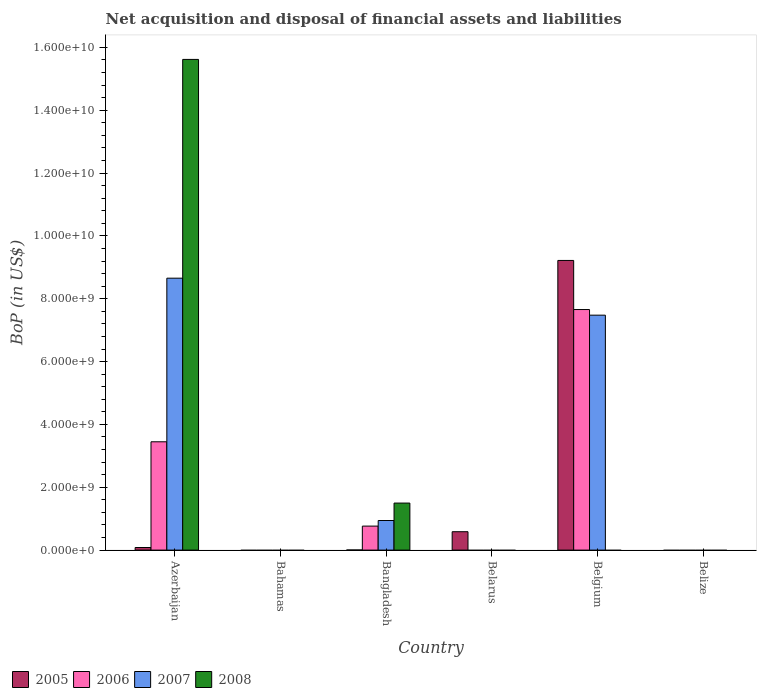How many different coloured bars are there?
Provide a succinct answer. 4. Are the number of bars per tick equal to the number of legend labels?
Offer a terse response. No. How many bars are there on the 4th tick from the left?
Provide a succinct answer. 1. How many bars are there on the 3rd tick from the right?
Make the answer very short. 1. What is the label of the 5th group of bars from the left?
Provide a succinct answer. Belgium. What is the Balance of Payments in 2006 in Bangladesh?
Your response must be concise. 7.64e+08. Across all countries, what is the maximum Balance of Payments in 2008?
Your answer should be very brief. 1.56e+1. Across all countries, what is the minimum Balance of Payments in 2007?
Ensure brevity in your answer.  0. In which country was the Balance of Payments in 2007 maximum?
Keep it short and to the point. Azerbaijan. What is the total Balance of Payments in 2006 in the graph?
Offer a very short reply. 1.19e+1. What is the difference between the Balance of Payments in 2006 in Azerbaijan and that in Bangladesh?
Your answer should be very brief. 2.68e+09. What is the difference between the Balance of Payments in 2006 in Azerbaijan and the Balance of Payments in 2007 in Belize?
Provide a succinct answer. 3.45e+09. What is the average Balance of Payments in 2006 per country?
Keep it short and to the point. 1.98e+09. What is the difference between the Balance of Payments of/in 2007 and Balance of Payments of/in 2006 in Azerbaijan?
Give a very brief answer. 5.21e+09. What is the difference between the highest and the second highest Balance of Payments in 2005?
Give a very brief answer. 5.03e+08. What is the difference between the highest and the lowest Balance of Payments in 2005?
Provide a succinct answer. 9.22e+09. How many bars are there?
Provide a succinct answer. 12. What is the difference between two consecutive major ticks on the Y-axis?
Keep it short and to the point. 2.00e+09. Are the values on the major ticks of Y-axis written in scientific E-notation?
Provide a succinct answer. Yes. Does the graph contain grids?
Offer a very short reply. No. Where does the legend appear in the graph?
Your answer should be very brief. Bottom left. What is the title of the graph?
Ensure brevity in your answer.  Net acquisition and disposal of financial assets and liabilities. Does "1961" appear as one of the legend labels in the graph?
Your answer should be very brief. No. What is the label or title of the X-axis?
Your answer should be very brief. Country. What is the label or title of the Y-axis?
Ensure brevity in your answer.  BoP (in US$). What is the BoP (in US$) in 2005 in Azerbaijan?
Your answer should be very brief. 8.26e+07. What is the BoP (in US$) of 2006 in Azerbaijan?
Ensure brevity in your answer.  3.45e+09. What is the BoP (in US$) in 2007 in Azerbaijan?
Offer a very short reply. 8.66e+09. What is the BoP (in US$) of 2008 in Azerbaijan?
Offer a very short reply. 1.56e+1. What is the BoP (in US$) of 2005 in Bahamas?
Ensure brevity in your answer.  0. What is the BoP (in US$) of 2006 in Bahamas?
Make the answer very short. 0. What is the BoP (in US$) of 2007 in Bahamas?
Offer a very short reply. 0. What is the BoP (in US$) in 2005 in Bangladesh?
Your answer should be very brief. 3.42e+06. What is the BoP (in US$) in 2006 in Bangladesh?
Ensure brevity in your answer.  7.64e+08. What is the BoP (in US$) in 2007 in Bangladesh?
Your answer should be very brief. 9.42e+08. What is the BoP (in US$) in 2008 in Bangladesh?
Provide a succinct answer. 1.50e+09. What is the BoP (in US$) in 2005 in Belarus?
Your response must be concise. 5.85e+08. What is the BoP (in US$) in 2005 in Belgium?
Your response must be concise. 9.22e+09. What is the BoP (in US$) of 2006 in Belgium?
Make the answer very short. 7.66e+09. What is the BoP (in US$) in 2007 in Belgium?
Your answer should be compact. 7.48e+09. What is the BoP (in US$) of 2005 in Belize?
Your answer should be compact. 0. What is the BoP (in US$) of 2006 in Belize?
Ensure brevity in your answer.  0. Across all countries, what is the maximum BoP (in US$) of 2005?
Ensure brevity in your answer.  9.22e+09. Across all countries, what is the maximum BoP (in US$) in 2006?
Your answer should be very brief. 7.66e+09. Across all countries, what is the maximum BoP (in US$) in 2007?
Your answer should be compact. 8.66e+09. Across all countries, what is the maximum BoP (in US$) of 2008?
Keep it short and to the point. 1.56e+1. Across all countries, what is the minimum BoP (in US$) in 2005?
Provide a short and direct response. 0. Across all countries, what is the minimum BoP (in US$) of 2006?
Offer a very short reply. 0. Across all countries, what is the minimum BoP (in US$) of 2007?
Your answer should be very brief. 0. Across all countries, what is the minimum BoP (in US$) in 2008?
Give a very brief answer. 0. What is the total BoP (in US$) in 2005 in the graph?
Give a very brief answer. 9.89e+09. What is the total BoP (in US$) of 2006 in the graph?
Your answer should be compact. 1.19e+1. What is the total BoP (in US$) in 2007 in the graph?
Offer a terse response. 1.71e+1. What is the total BoP (in US$) of 2008 in the graph?
Ensure brevity in your answer.  1.71e+1. What is the difference between the BoP (in US$) in 2005 in Azerbaijan and that in Bangladesh?
Your response must be concise. 7.92e+07. What is the difference between the BoP (in US$) in 2006 in Azerbaijan and that in Bangladesh?
Your answer should be compact. 2.68e+09. What is the difference between the BoP (in US$) in 2007 in Azerbaijan and that in Bangladesh?
Provide a succinct answer. 7.71e+09. What is the difference between the BoP (in US$) of 2008 in Azerbaijan and that in Bangladesh?
Offer a very short reply. 1.41e+1. What is the difference between the BoP (in US$) in 2005 in Azerbaijan and that in Belarus?
Provide a short and direct response. -5.03e+08. What is the difference between the BoP (in US$) of 2005 in Azerbaijan and that in Belgium?
Offer a terse response. -9.14e+09. What is the difference between the BoP (in US$) of 2006 in Azerbaijan and that in Belgium?
Keep it short and to the point. -4.21e+09. What is the difference between the BoP (in US$) in 2007 in Azerbaijan and that in Belgium?
Provide a short and direct response. 1.18e+09. What is the difference between the BoP (in US$) in 2005 in Bangladesh and that in Belarus?
Offer a terse response. -5.82e+08. What is the difference between the BoP (in US$) in 2005 in Bangladesh and that in Belgium?
Make the answer very short. -9.22e+09. What is the difference between the BoP (in US$) of 2006 in Bangladesh and that in Belgium?
Keep it short and to the point. -6.89e+09. What is the difference between the BoP (in US$) of 2007 in Bangladesh and that in Belgium?
Your response must be concise. -6.54e+09. What is the difference between the BoP (in US$) in 2005 in Belarus and that in Belgium?
Keep it short and to the point. -8.63e+09. What is the difference between the BoP (in US$) of 2005 in Azerbaijan and the BoP (in US$) of 2006 in Bangladesh?
Offer a very short reply. -6.81e+08. What is the difference between the BoP (in US$) in 2005 in Azerbaijan and the BoP (in US$) in 2007 in Bangladesh?
Keep it short and to the point. -8.59e+08. What is the difference between the BoP (in US$) of 2005 in Azerbaijan and the BoP (in US$) of 2008 in Bangladesh?
Provide a short and direct response. -1.41e+09. What is the difference between the BoP (in US$) in 2006 in Azerbaijan and the BoP (in US$) in 2007 in Bangladesh?
Your answer should be very brief. 2.51e+09. What is the difference between the BoP (in US$) in 2006 in Azerbaijan and the BoP (in US$) in 2008 in Bangladesh?
Offer a terse response. 1.95e+09. What is the difference between the BoP (in US$) in 2007 in Azerbaijan and the BoP (in US$) in 2008 in Bangladesh?
Provide a short and direct response. 7.16e+09. What is the difference between the BoP (in US$) of 2005 in Azerbaijan and the BoP (in US$) of 2006 in Belgium?
Make the answer very short. -7.57e+09. What is the difference between the BoP (in US$) in 2005 in Azerbaijan and the BoP (in US$) in 2007 in Belgium?
Offer a very short reply. -7.40e+09. What is the difference between the BoP (in US$) of 2006 in Azerbaijan and the BoP (in US$) of 2007 in Belgium?
Your answer should be very brief. -4.03e+09. What is the difference between the BoP (in US$) in 2005 in Bangladesh and the BoP (in US$) in 2006 in Belgium?
Your answer should be very brief. -7.65e+09. What is the difference between the BoP (in US$) in 2005 in Bangladesh and the BoP (in US$) in 2007 in Belgium?
Keep it short and to the point. -7.47e+09. What is the difference between the BoP (in US$) in 2006 in Bangladesh and the BoP (in US$) in 2007 in Belgium?
Your answer should be compact. -6.71e+09. What is the difference between the BoP (in US$) of 2005 in Belarus and the BoP (in US$) of 2006 in Belgium?
Give a very brief answer. -7.07e+09. What is the difference between the BoP (in US$) of 2005 in Belarus and the BoP (in US$) of 2007 in Belgium?
Make the answer very short. -6.89e+09. What is the average BoP (in US$) in 2005 per country?
Your response must be concise. 1.65e+09. What is the average BoP (in US$) of 2006 per country?
Provide a short and direct response. 1.98e+09. What is the average BoP (in US$) of 2007 per country?
Provide a succinct answer. 2.85e+09. What is the average BoP (in US$) of 2008 per country?
Offer a very short reply. 2.85e+09. What is the difference between the BoP (in US$) in 2005 and BoP (in US$) in 2006 in Azerbaijan?
Provide a succinct answer. -3.37e+09. What is the difference between the BoP (in US$) of 2005 and BoP (in US$) of 2007 in Azerbaijan?
Offer a very short reply. -8.57e+09. What is the difference between the BoP (in US$) of 2005 and BoP (in US$) of 2008 in Azerbaijan?
Ensure brevity in your answer.  -1.55e+1. What is the difference between the BoP (in US$) of 2006 and BoP (in US$) of 2007 in Azerbaijan?
Make the answer very short. -5.21e+09. What is the difference between the BoP (in US$) in 2006 and BoP (in US$) in 2008 in Azerbaijan?
Offer a terse response. -1.22e+1. What is the difference between the BoP (in US$) in 2007 and BoP (in US$) in 2008 in Azerbaijan?
Provide a short and direct response. -6.96e+09. What is the difference between the BoP (in US$) in 2005 and BoP (in US$) in 2006 in Bangladesh?
Offer a very short reply. -7.60e+08. What is the difference between the BoP (in US$) of 2005 and BoP (in US$) of 2007 in Bangladesh?
Offer a terse response. -9.39e+08. What is the difference between the BoP (in US$) in 2005 and BoP (in US$) in 2008 in Bangladesh?
Ensure brevity in your answer.  -1.49e+09. What is the difference between the BoP (in US$) in 2006 and BoP (in US$) in 2007 in Bangladesh?
Keep it short and to the point. -1.78e+08. What is the difference between the BoP (in US$) of 2006 and BoP (in US$) of 2008 in Bangladesh?
Give a very brief answer. -7.33e+08. What is the difference between the BoP (in US$) of 2007 and BoP (in US$) of 2008 in Bangladesh?
Make the answer very short. -5.55e+08. What is the difference between the BoP (in US$) of 2005 and BoP (in US$) of 2006 in Belgium?
Make the answer very short. 1.56e+09. What is the difference between the BoP (in US$) of 2005 and BoP (in US$) of 2007 in Belgium?
Offer a very short reply. 1.74e+09. What is the difference between the BoP (in US$) in 2006 and BoP (in US$) in 2007 in Belgium?
Provide a short and direct response. 1.79e+08. What is the ratio of the BoP (in US$) of 2005 in Azerbaijan to that in Bangladesh?
Keep it short and to the point. 24.16. What is the ratio of the BoP (in US$) of 2006 in Azerbaijan to that in Bangladesh?
Your answer should be very brief. 4.51. What is the ratio of the BoP (in US$) of 2007 in Azerbaijan to that in Bangladesh?
Your answer should be very brief. 9.19. What is the ratio of the BoP (in US$) of 2008 in Azerbaijan to that in Bangladesh?
Offer a terse response. 10.43. What is the ratio of the BoP (in US$) of 2005 in Azerbaijan to that in Belarus?
Offer a very short reply. 0.14. What is the ratio of the BoP (in US$) in 2005 in Azerbaijan to that in Belgium?
Your answer should be compact. 0.01. What is the ratio of the BoP (in US$) in 2006 in Azerbaijan to that in Belgium?
Provide a succinct answer. 0.45. What is the ratio of the BoP (in US$) of 2007 in Azerbaijan to that in Belgium?
Offer a terse response. 1.16. What is the ratio of the BoP (in US$) of 2005 in Bangladesh to that in Belarus?
Offer a very short reply. 0.01. What is the ratio of the BoP (in US$) of 2006 in Bangladesh to that in Belgium?
Offer a very short reply. 0.1. What is the ratio of the BoP (in US$) of 2007 in Bangladesh to that in Belgium?
Offer a very short reply. 0.13. What is the ratio of the BoP (in US$) of 2005 in Belarus to that in Belgium?
Keep it short and to the point. 0.06. What is the difference between the highest and the second highest BoP (in US$) of 2005?
Your answer should be compact. 8.63e+09. What is the difference between the highest and the second highest BoP (in US$) in 2006?
Offer a very short reply. 4.21e+09. What is the difference between the highest and the second highest BoP (in US$) in 2007?
Provide a short and direct response. 1.18e+09. What is the difference between the highest and the lowest BoP (in US$) in 2005?
Your answer should be compact. 9.22e+09. What is the difference between the highest and the lowest BoP (in US$) in 2006?
Your answer should be compact. 7.66e+09. What is the difference between the highest and the lowest BoP (in US$) in 2007?
Offer a very short reply. 8.66e+09. What is the difference between the highest and the lowest BoP (in US$) in 2008?
Your response must be concise. 1.56e+1. 